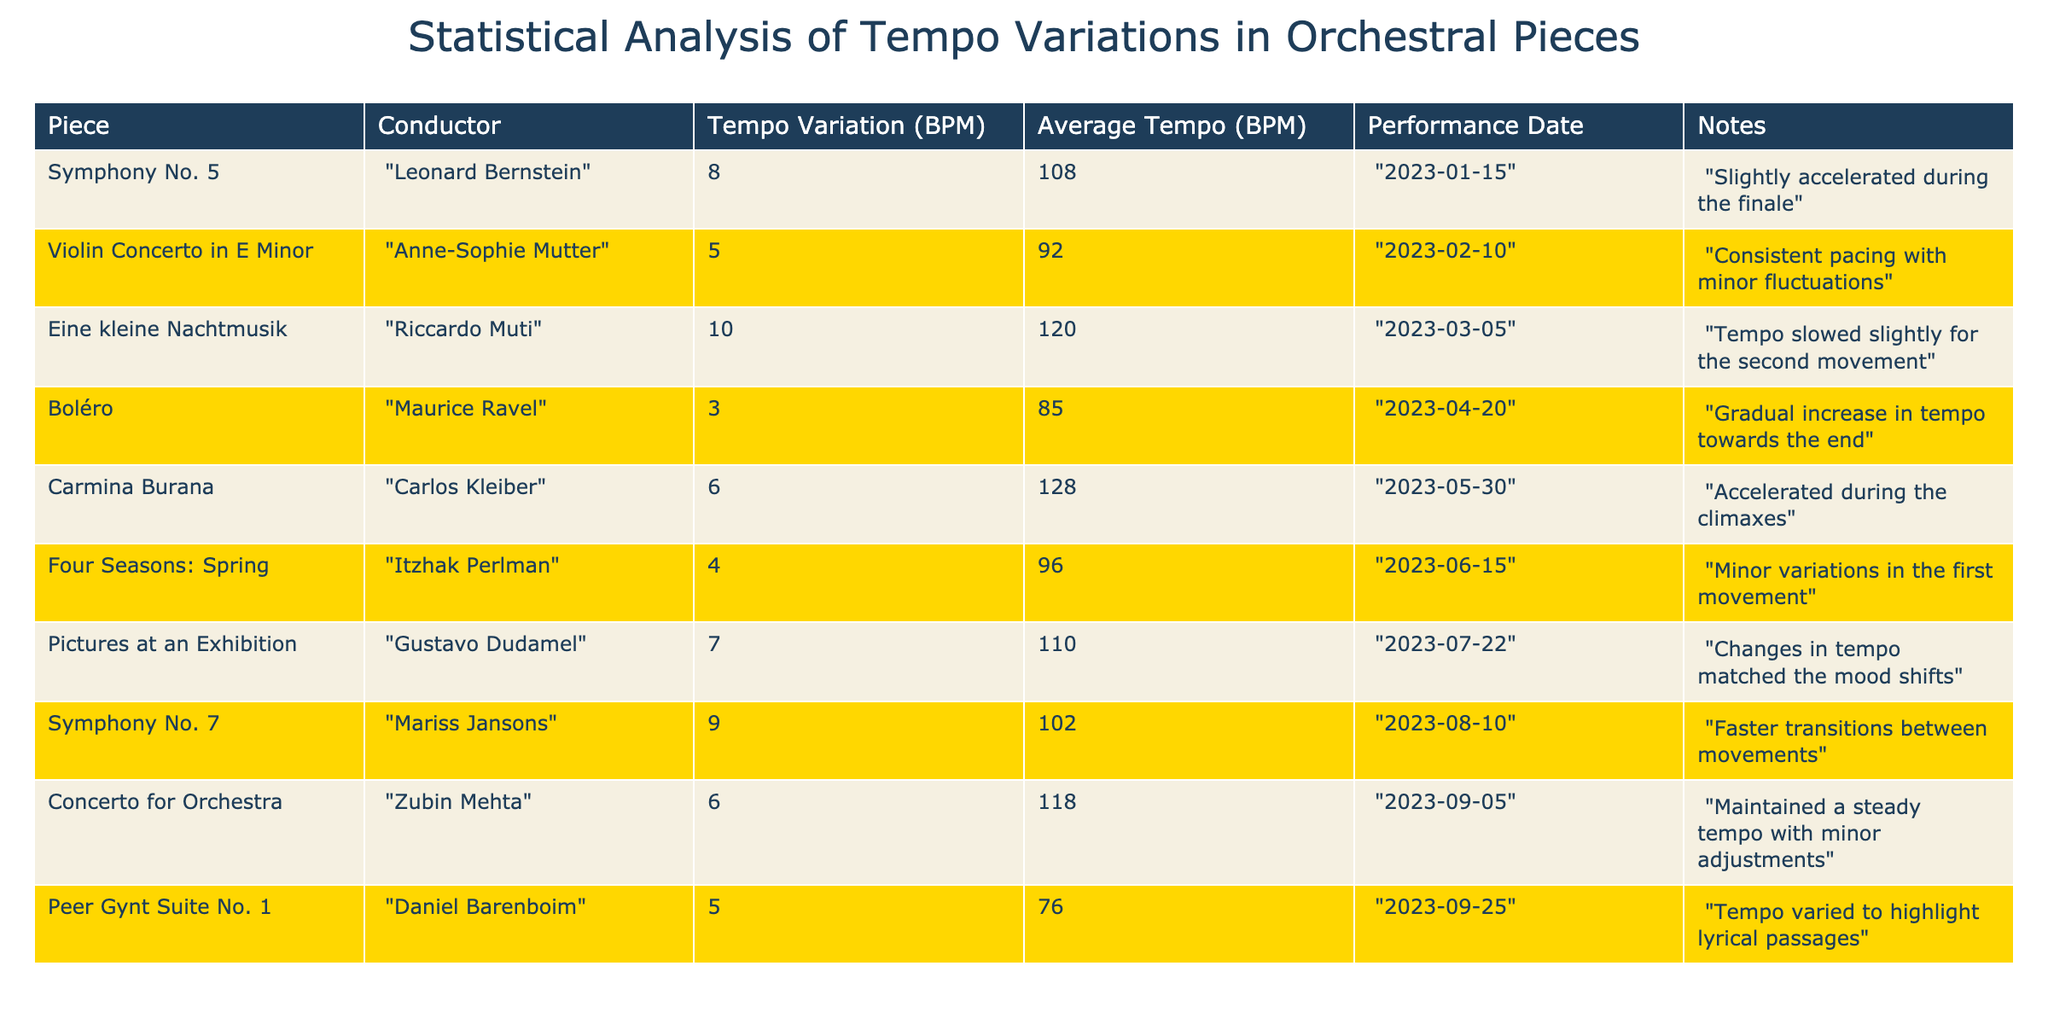What is the tempo variation for "Boléro"? The table shows that the tempo variation for "Boléro" is listed under the "Tempo Variation (BPM)" column where "Boléro" is mentioned, which is 3 BPM.
Answer: 3 BPM Who was the conductor for "Carmina Burana"? Looking at the "Conductor" column, "Carmina Burana" is paired with "Carlos Kleiber".
Answer: Carlos Kleiber What is the average tempo of "Symphony No. 7"? To find the average tempo for "Symphony No. 7," we can refer to the "Average Tempo (BPM)" column where it is listed, which states that the average tempo is 102 BPM.
Answer: 102 BPM Is there a piece that had a tempo variation greater than 9 BPM? We can examine the "Tempo Variation (BPM)" column to determine if any value exceeds 9 BPM. The highest tempo variation listed is 10 BPM for "Eine kleine Nachtmusik." Hence, the answer is yes.
Answer: Yes What is the difference in average tempo between the piece with the highest tempo variation and the piece with the lowest? First, identify the piece with the highest tempo variation, which is "Eine kleine Nachtmusik" at 10 BPM, and the piece with the lowest tempo variation, which is "Boléro" at 3 BPM. Next, look at their average tempos: "Eine kleine Nachtmusik" has an average tempo of 120 BPM and "Boléro" has an average tempo of 85 BPM. The difference is 120 - 85 = 35 BPM.
Answer: 35 BPM How many pieces were performed with an average tempo below 100 BPM? We can count the number of entries in the "Average Tempo (BPM)" column that are below 100 BPM: "Peer Gynt Suite No. 1" at 76 BPM, "Boléro" at 85 BPM, and "Violin Concerto in E Minor" at 92 BPM. This totals 3 pieces.
Answer: 3 pieces What was the performance date for "Four Seasons: Spring"? By searching the "Performance Date" column for "Four Seasons: Spring," it states the performance took place on "2023-06-15."
Answer: 2023-06-15 Which conductor performed the "Pictures at an Exhibition," and was there any note regarding tempo changes? The conductor for "Pictures at an Exhibition" is "Gustavo Dudamel." The notes indicate that "Changes in tempo matched the mood shifts."
Answer: Gustavo Dudamel; Yes, there was a note 